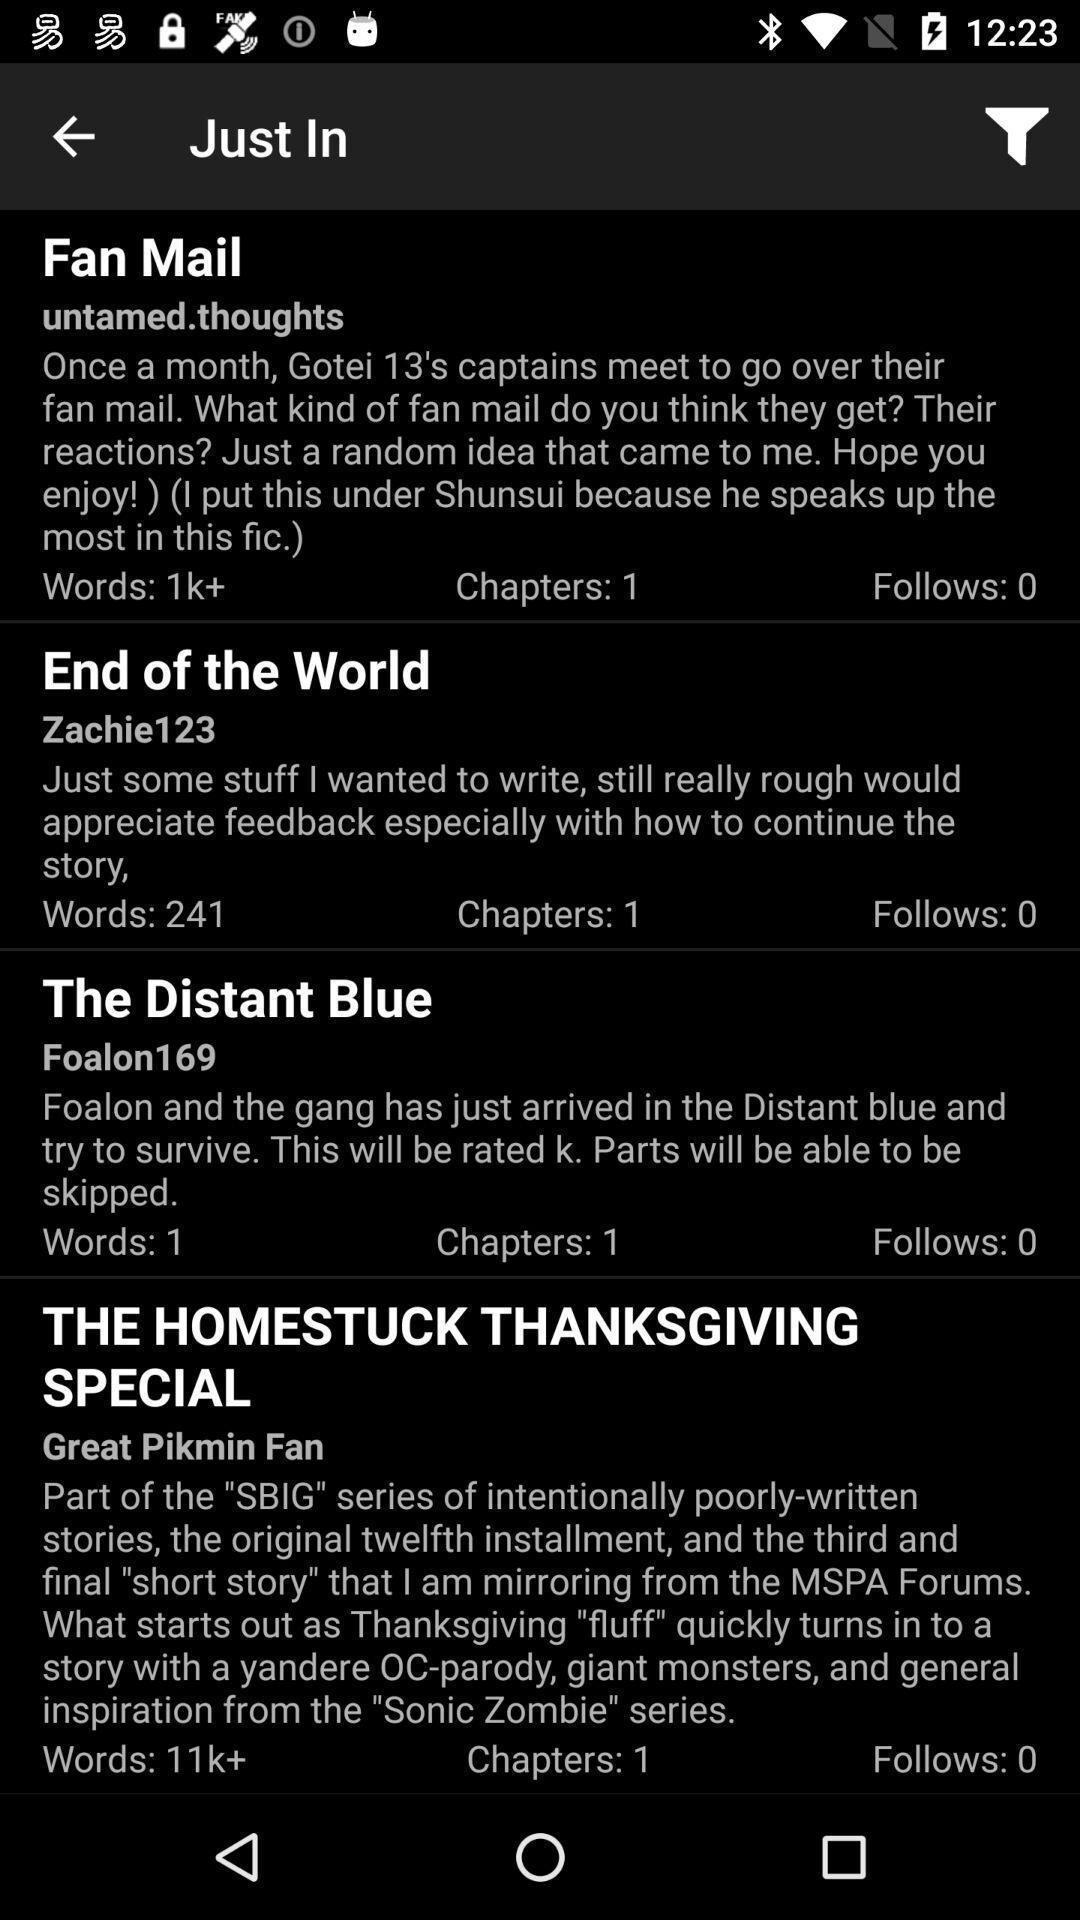What details can you identify in this image? Various feed displayed of an browsing app. 